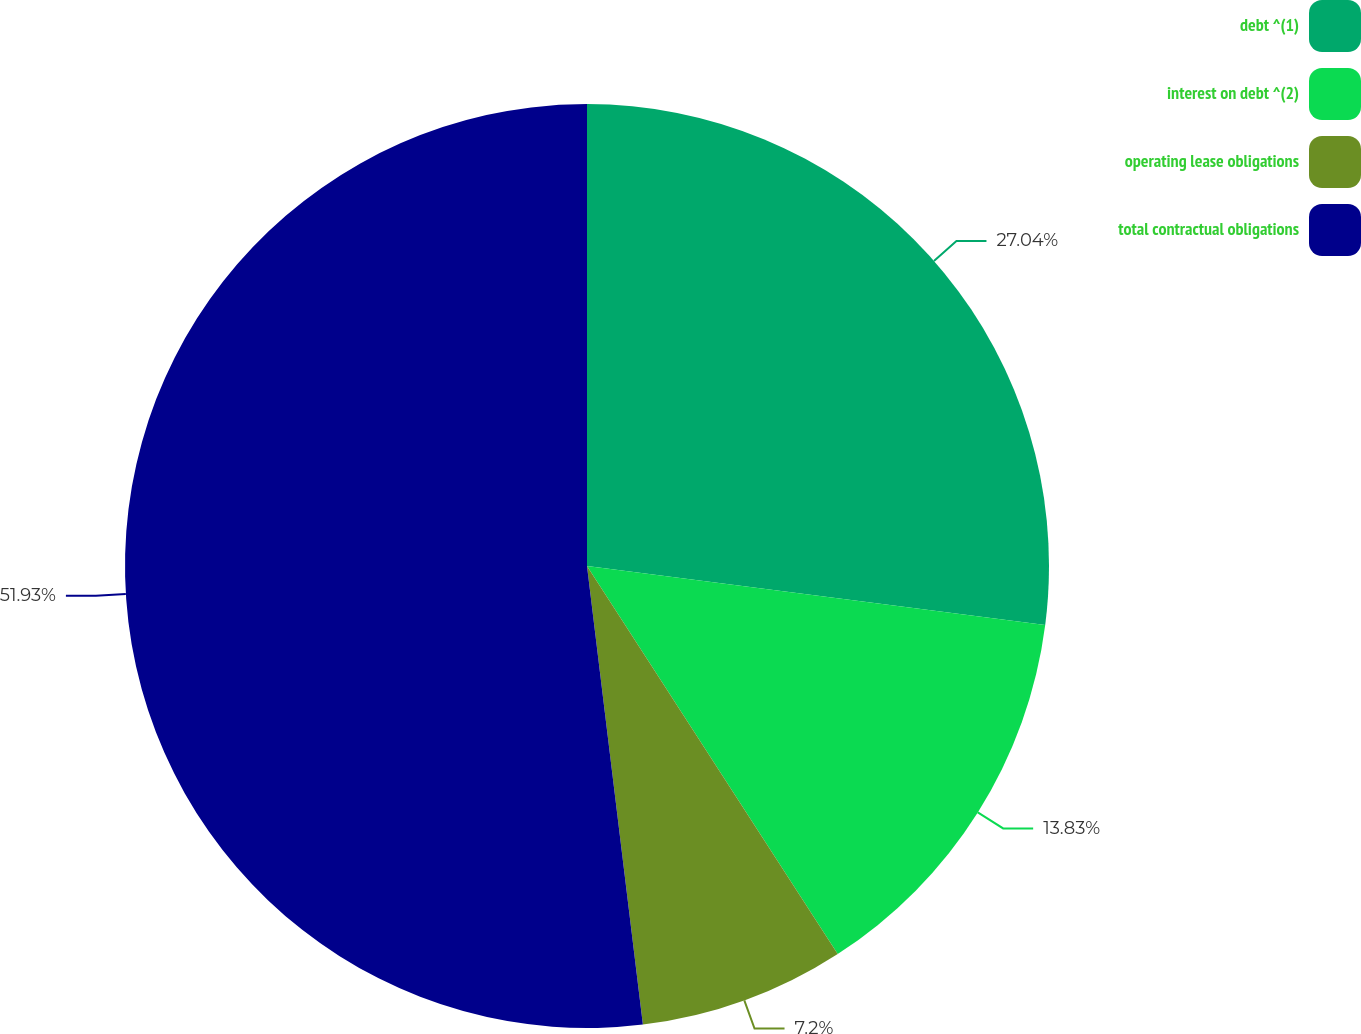Convert chart to OTSL. <chart><loc_0><loc_0><loc_500><loc_500><pie_chart><fcel>debt ^(1)<fcel>interest on debt ^(2)<fcel>operating lease obligations<fcel>total contractual obligations<nl><fcel>27.04%<fcel>13.83%<fcel>7.2%<fcel>51.93%<nl></chart> 